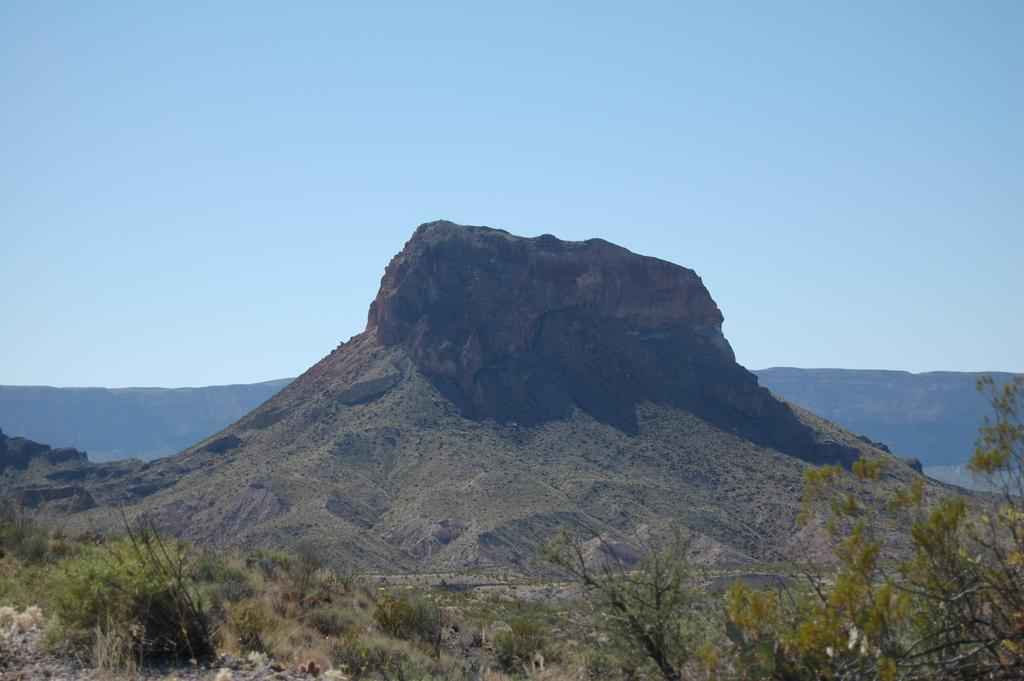What is the main feature in the image? There is a mountain in the image. What can be seen in the foreground of the image? There are plants in the foreground of the image. What type of scent can be detected from the mountain in the image? There is no indication of a scent in the image, as it is a visual representation. 